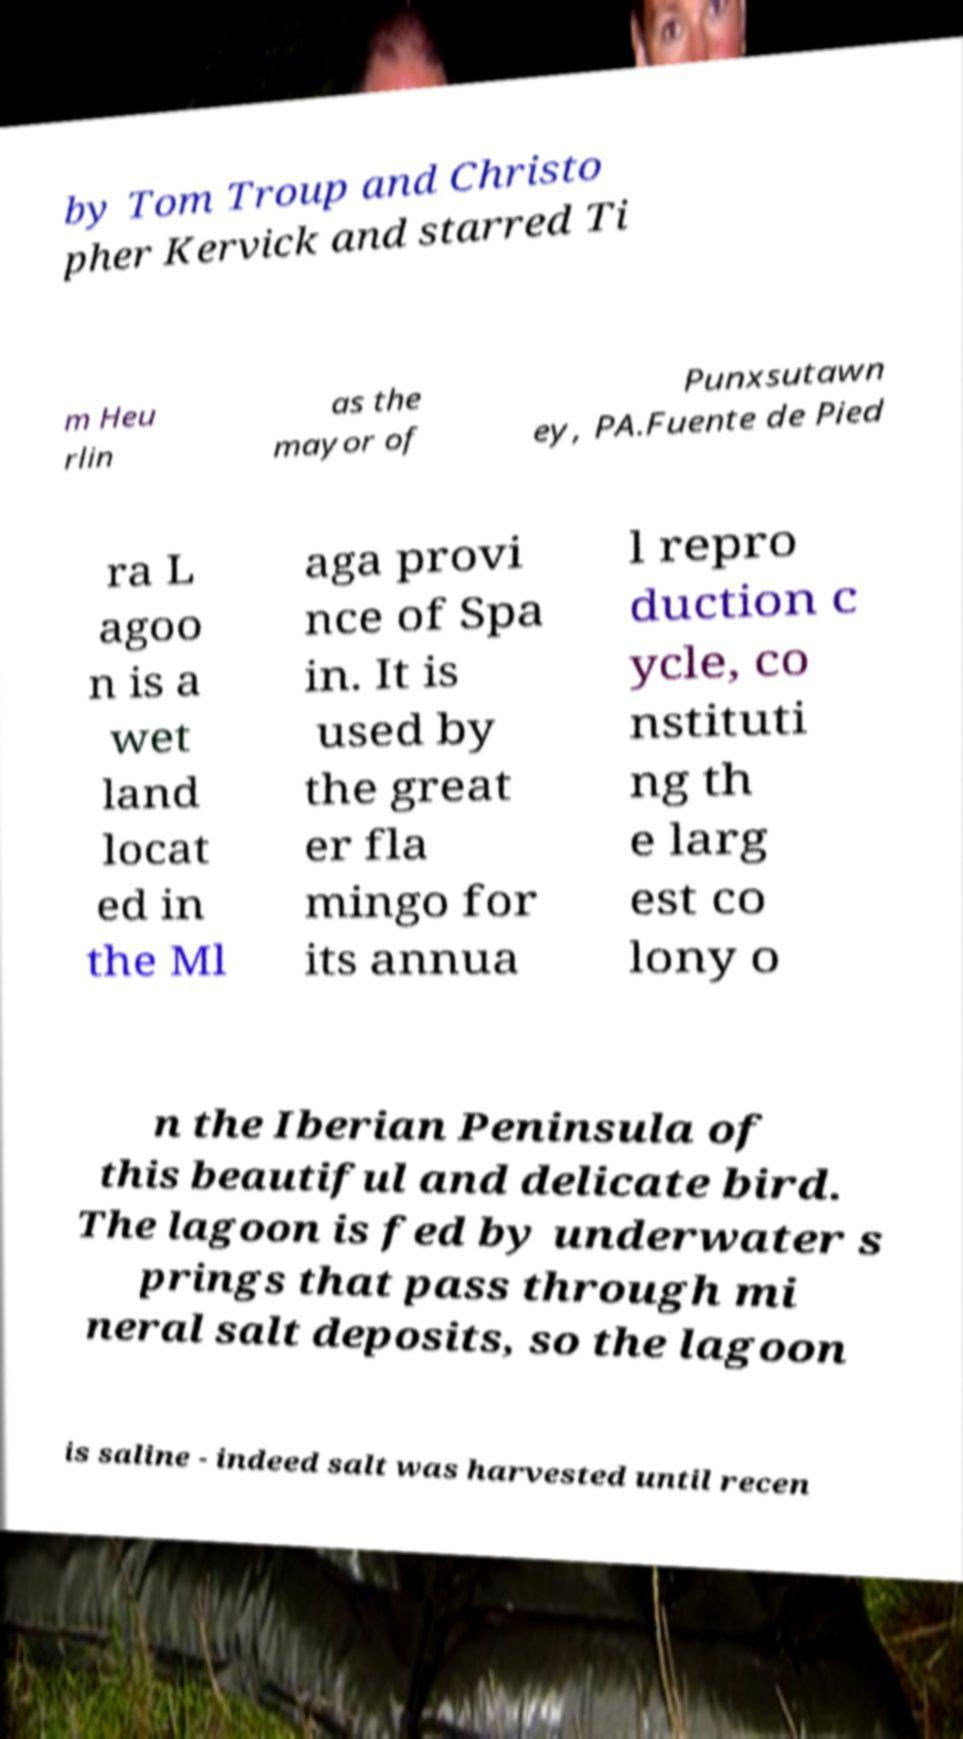Can you accurately transcribe the text from the provided image for me? by Tom Troup and Christo pher Kervick and starred Ti m Heu rlin as the mayor of Punxsutawn ey, PA.Fuente de Pied ra L agoo n is a wet land locat ed in the Ml aga provi nce of Spa in. It is used by the great er fla mingo for its annua l repro duction c ycle, co nstituti ng th e larg est co lony o n the Iberian Peninsula of this beautiful and delicate bird. The lagoon is fed by underwater s prings that pass through mi neral salt deposits, so the lagoon is saline - indeed salt was harvested until recen 